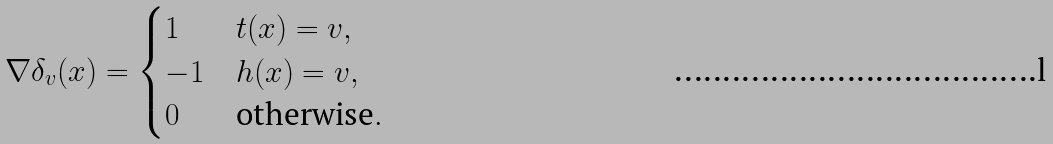<formula> <loc_0><loc_0><loc_500><loc_500>\nabla \delta _ { v } ( x ) = \begin{cases} 1 & t ( x ) = v , \\ - 1 & h ( x ) = v , \\ 0 & \text {otherwise} . \end{cases}</formula> 